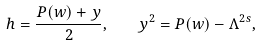Convert formula to latex. <formula><loc_0><loc_0><loc_500><loc_500>h = \frac { P ( w ) + y } { 2 } , \quad y ^ { 2 } = P ( w ) - \Lambda ^ { 2 s } ,</formula> 